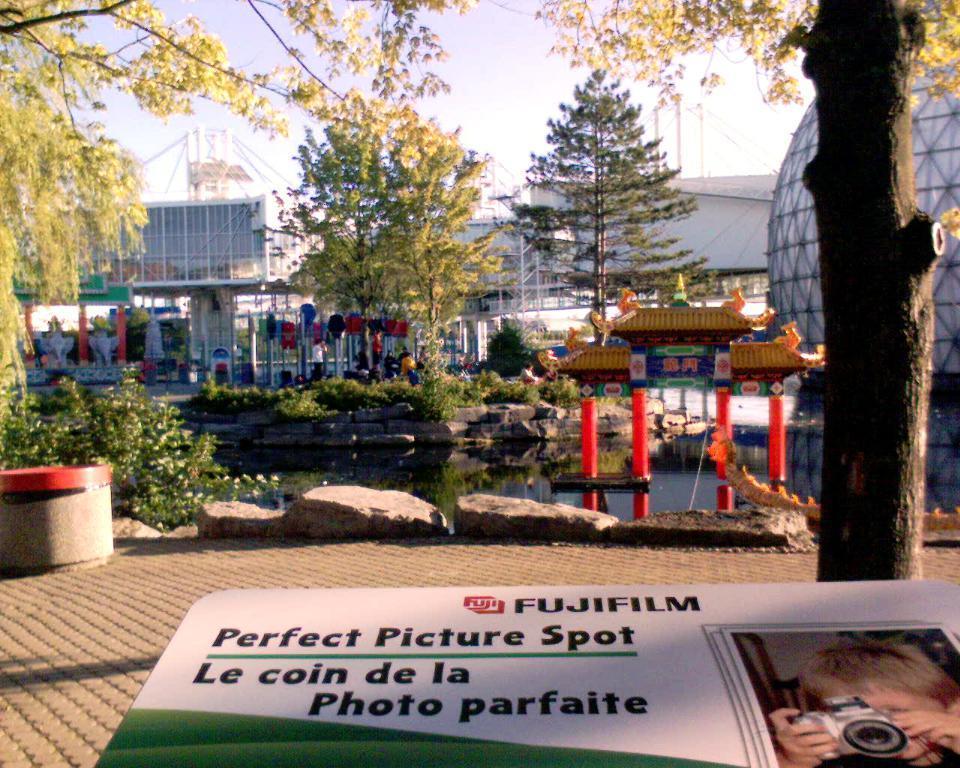Please provide a concise description of this image. In the front of the image there is a board. In the background of the image there are rocks, plants, trees, buildings, boards, pillars, water, sky and objects. Something is written on the board. On the board there is a picture of a person and camera 